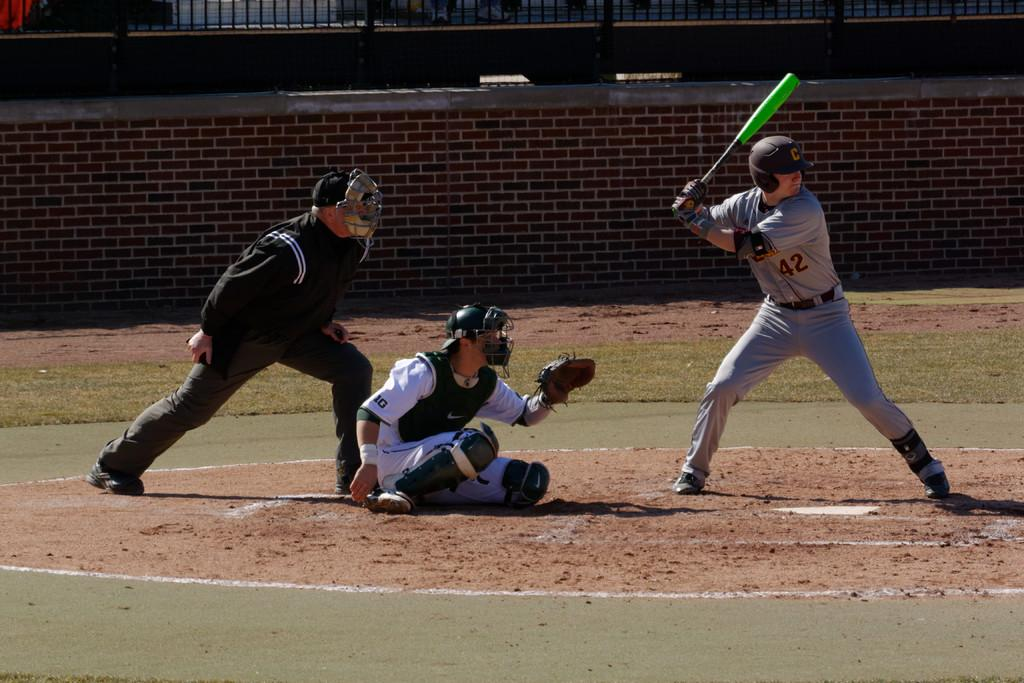Provide a one-sentence caption for the provided image. Player number 42 getting ready to swing at a pitch to try to hit a baseball. 